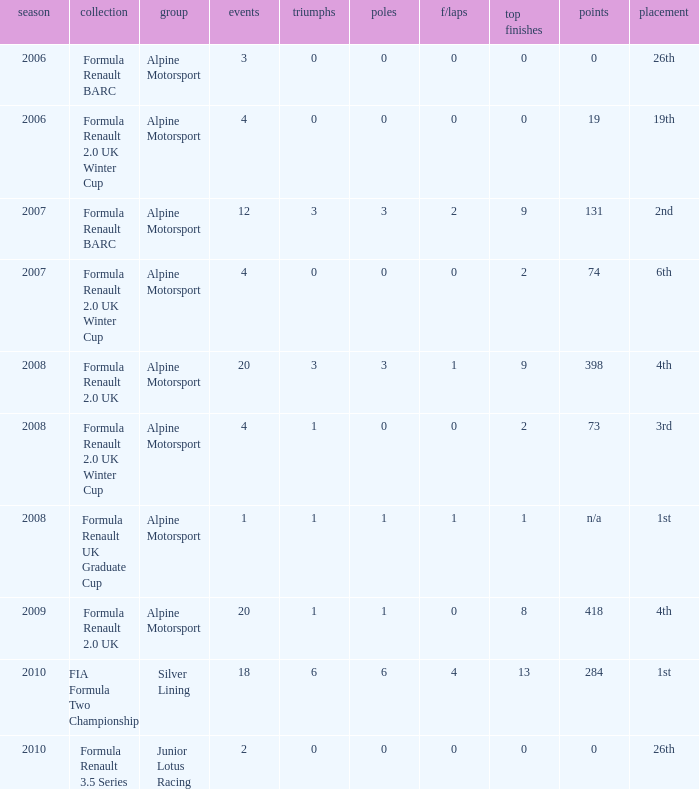How much were the f/laps if poles is higher than 1.0 during 2008? 1.0. 